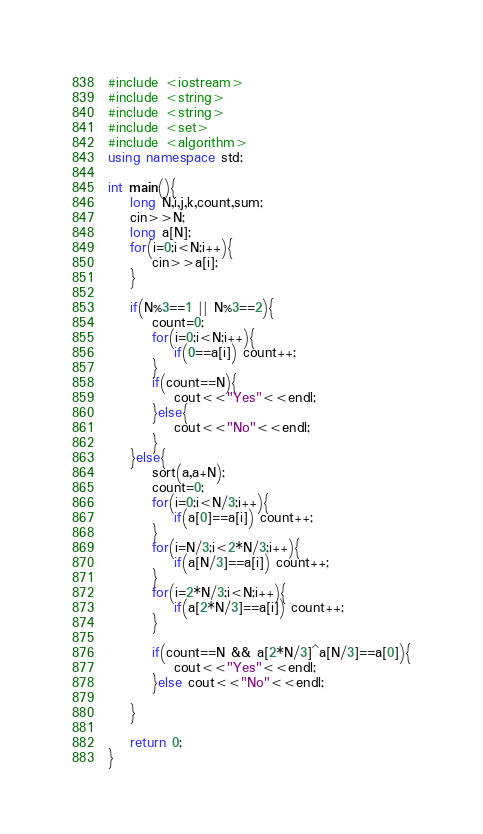<code> <loc_0><loc_0><loc_500><loc_500><_C++_>#include <iostream>
#include <string>
#include <string>
#include <set>
#include <algorithm>
using namespace std;

int main(){
	long N,i,j,k,count,sum;
	cin>>N;
	long a[N];
	for(i=0;i<N;i++){
		cin>>a[i];
	}
	
	if(N%3==1 || N%3==2){
		count=0;
		for(i=0;i<N;i++){
			if(0==a[i]) count++;
		}
		if(count==N){
			cout<<"Yes"<<endl;
		}else{
			cout<<"No"<<endl;
		}
	}else{
		sort(a,a+N);
		count=0;
		for(i=0;i<N/3;i++){
			if(a[0]==a[i]) count++;
		}
		for(i=N/3;i<2*N/3;i++){
			if(a[N/3]==a[i]) count++;
		}
		for(i=2*N/3;i<N;i++){
			if(a[2*N/3]==a[i]) count++;
		}
		
		if(count==N && a[2*N/3]^a[N/3]==a[0]){
			cout<<"Yes"<<endl;
		}else cout<<"No"<<endl;
		
	}
	
	return 0;
}</code> 